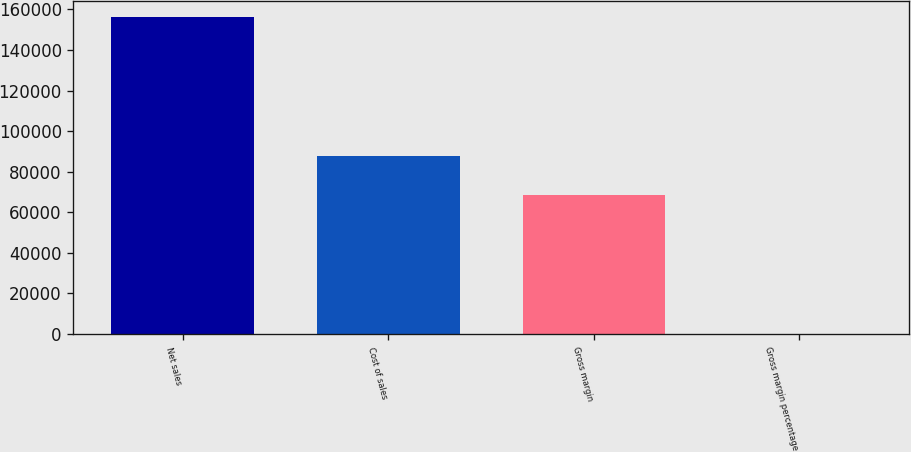<chart> <loc_0><loc_0><loc_500><loc_500><bar_chart><fcel>Net sales<fcel>Cost of sales<fcel>Gross margin<fcel>Gross margin percentage<nl><fcel>156508<fcel>87846<fcel>68662<fcel>43.9<nl></chart> 